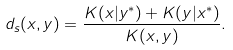Convert formula to latex. <formula><loc_0><loc_0><loc_500><loc_500>d _ { s } ( x , y ) = \frac { K ( x | y ^ { * } ) + K ( y | x ^ { * } ) } { K ( x , y ) } .</formula> 